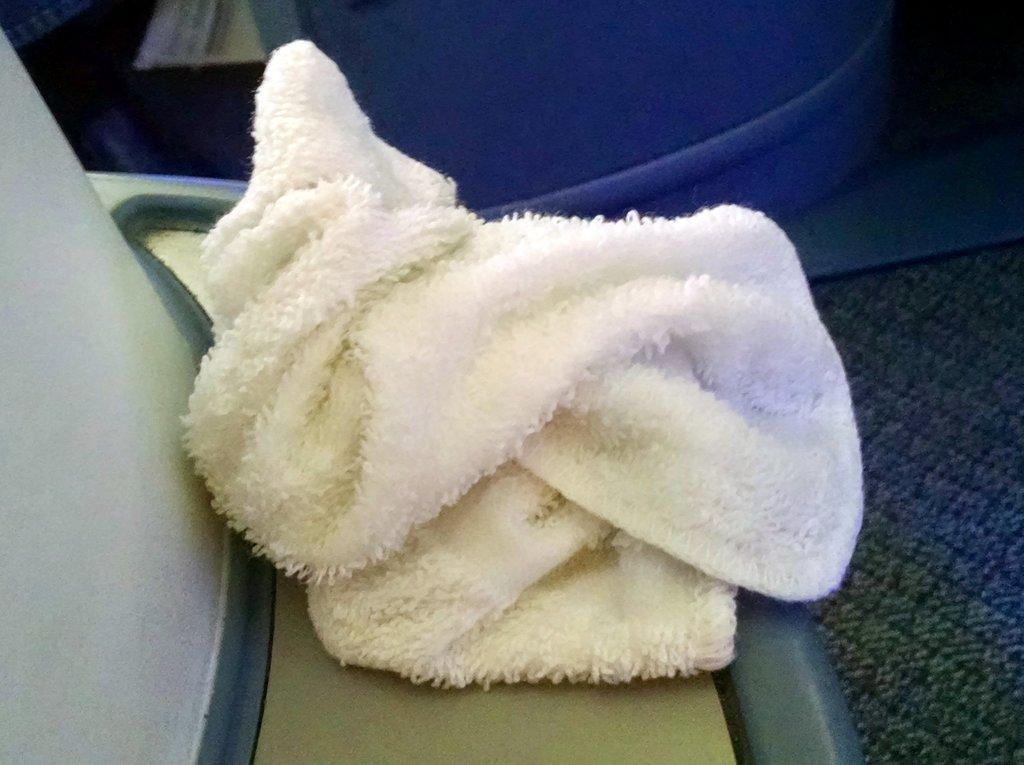What is placed on the platform in the image? There is cloth on a platform in the image. Can you describe the background of the image? There are objects in the background of the image. What type of celery is being harvested by the farmer in the image? There is no farmer or celery present in the image; it only features cloth on a platform and objects in the background. 